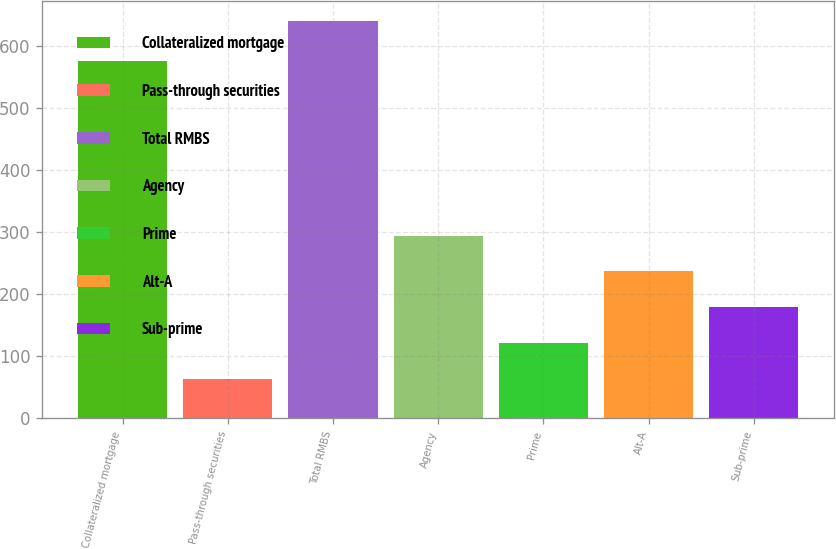<chart> <loc_0><loc_0><loc_500><loc_500><bar_chart><fcel>Collateralized mortgage<fcel>Pass-through securities<fcel>Total RMBS<fcel>Agency<fcel>Prime<fcel>Alt-A<fcel>Sub-prime<nl><fcel>575<fcel>64<fcel>639<fcel>294<fcel>121.5<fcel>236.5<fcel>179<nl></chart> 